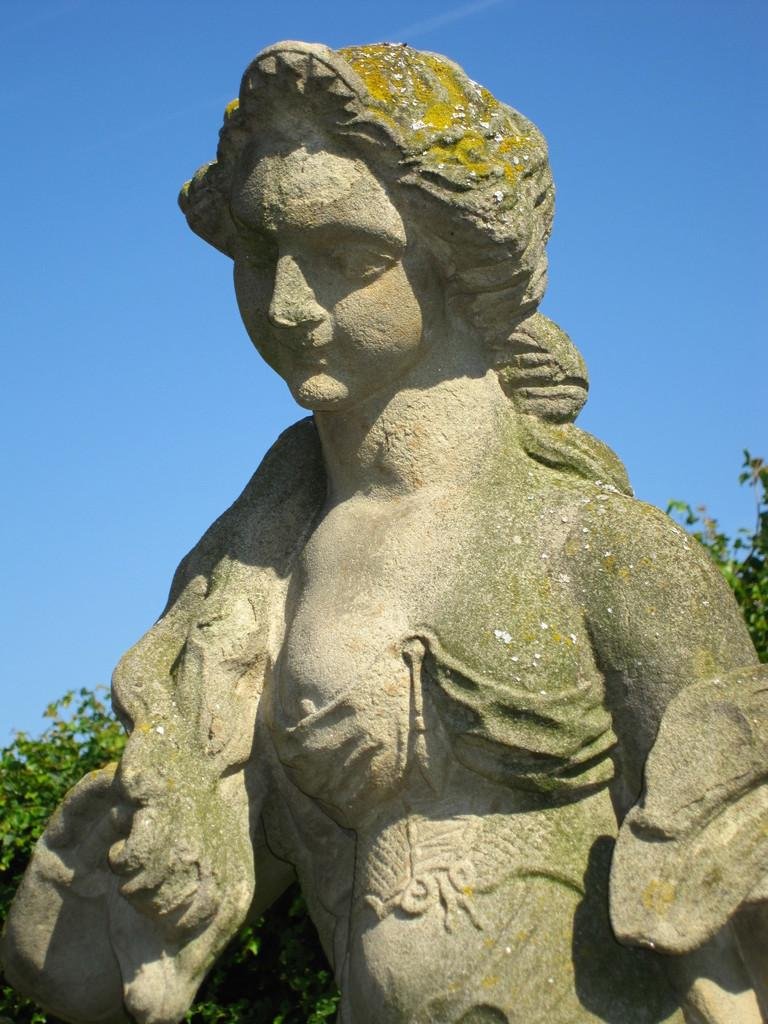What is the main subject of the image? There is a sculpture of a person in the image. What can be seen in the background of the image? There are trees and the sky visible in the background of the image. What type of operation is being performed on the sculpture in the image? There is no operation being performed on the sculpture in the image; it is a static sculpture. How many baseballs can be seen in the image? There are no baseballs present in the image. 